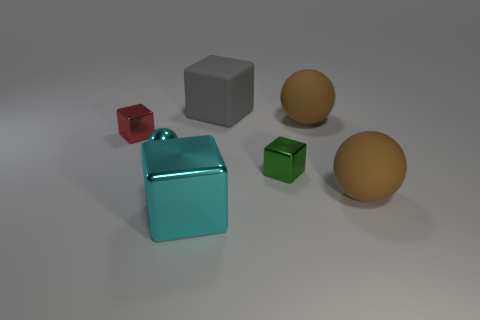Are there an equal number of green metallic cubes behind the small green block and things that are left of the tiny cyan thing?
Offer a terse response. No. What shape is the large brown rubber object in front of the red block?
Your answer should be very brief. Sphere. What shape is the gray rubber object that is the same size as the cyan cube?
Offer a terse response. Cube. What is the color of the big rubber thing that is behind the big brown matte thing that is behind the ball left of the gray matte cube?
Give a very brief answer. Gray. Does the tiny red shiny object have the same shape as the big cyan metal object?
Provide a succinct answer. Yes. Are there the same number of big rubber spheres that are on the left side of the big cyan metallic cube and tiny blocks?
Offer a terse response. No. How many other objects are the same material as the gray thing?
Keep it short and to the point. 2. There is a shiny object right of the gray rubber thing; does it have the same size as the brown thing that is behind the small cyan metallic ball?
Your answer should be very brief. No. How many objects are either large brown balls that are in front of the green thing or brown matte spheres in front of the green thing?
Offer a terse response. 1. Is the color of the big matte sphere that is in front of the red block the same as the sphere behind the tiny sphere?
Keep it short and to the point. Yes. 